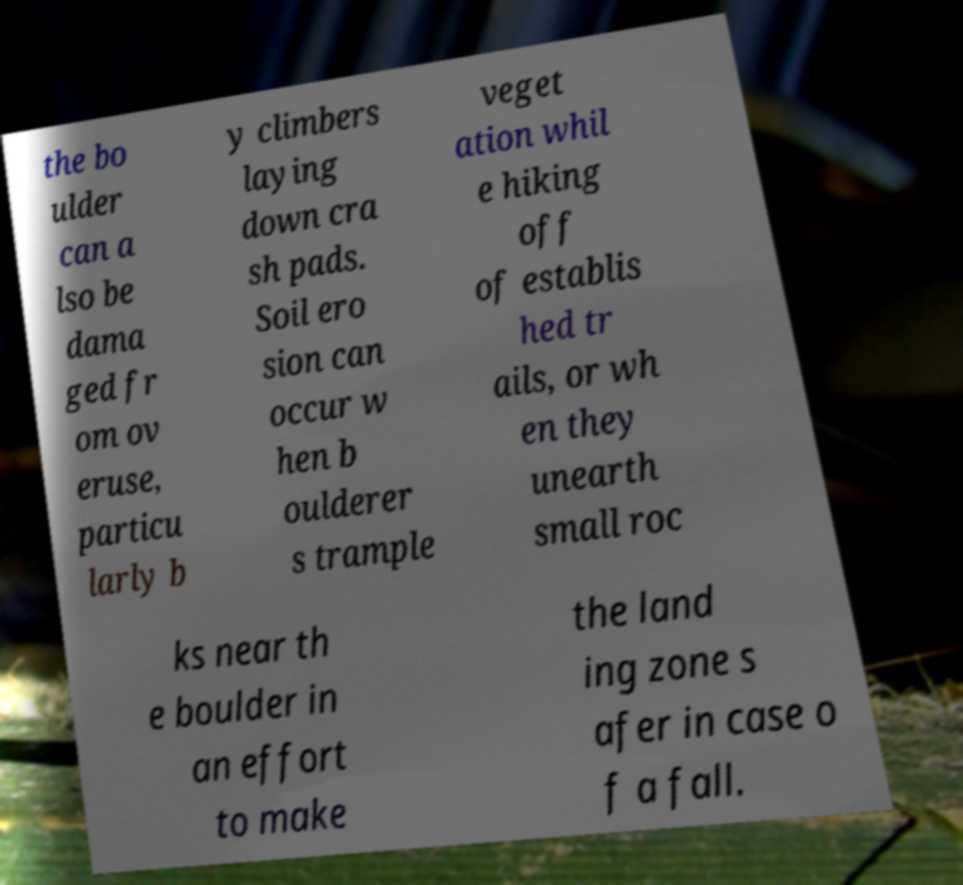For documentation purposes, I need the text within this image transcribed. Could you provide that? the bo ulder can a lso be dama ged fr om ov eruse, particu larly b y climbers laying down cra sh pads. Soil ero sion can occur w hen b oulderer s trample veget ation whil e hiking off of establis hed tr ails, or wh en they unearth small roc ks near th e boulder in an effort to make the land ing zone s afer in case o f a fall. 